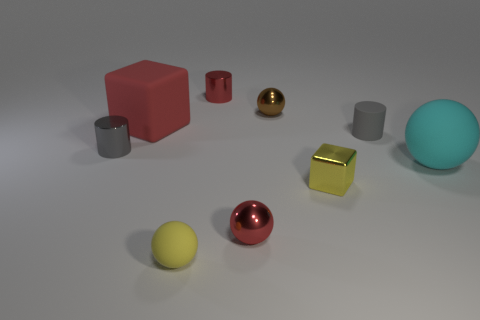What number of blue rubber cubes have the same size as the matte cylinder?
Give a very brief answer. 0. There is a object that is the same color as the rubber cylinder; what is its shape?
Keep it short and to the point. Cylinder. Are there any small gray metal objects of the same shape as the large red object?
Keep it short and to the point. No. The matte ball that is the same size as the brown metallic object is what color?
Give a very brief answer. Yellow. The cylinder behind the matte thing left of the small yellow rubber thing is what color?
Offer a terse response. Red. There is a small metallic ball in front of the brown ball; is its color the same as the large block?
Give a very brief answer. Yes. The small gray thing right of the cube right of the cube behind the tiny metal block is what shape?
Your answer should be compact. Cylinder. What number of large red objects are in front of the shiny cylinder that is in front of the tiny brown shiny thing?
Keep it short and to the point. 0. Are the small red sphere and the brown thing made of the same material?
Ensure brevity in your answer.  Yes. What number of yellow objects are on the left side of the red thing that is on the right side of the metal thing that is behind the brown sphere?
Your answer should be very brief. 1. 